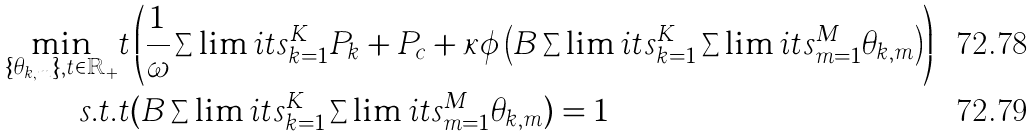Convert formula to latex. <formula><loc_0><loc_0><loc_500><loc_500>\min _ { \{ \theta _ { k , m } \} , t \in \mathbb { R } _ { + } } & t \left ( { \frac { 1 } { \omega } \sum \lim i t s _ { k = 1 } ^ { K } P _ { k } + P _ { c } + \kappa \phi \left ( B \sum \lim i t s _ { k = 1 } ^ { K } \sum \lim i t s _ { m = 1 } ^ { M } \theta _ { k , m } \right ) } \right ) \\ s . t . & t ( B \sum \lim i t s _ { k = 1 } ^ { K } \sum \lim i t s _ { m = 1 } ^ { M } \theta _ { k , m } ) = 1</formula> 